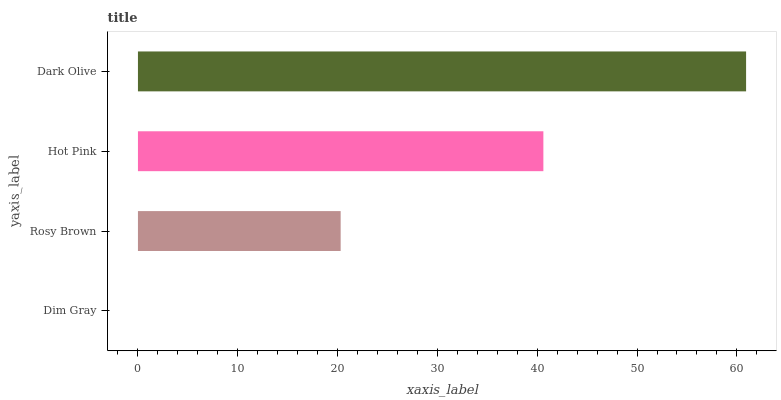Is Dim Gray the minimum?
Answer yes or no. Yes. Is Dark Olive the maximum?
Answer yes or no. Yes. Is Rosy Brown the minimum?
Answer yes or no. No. Is Rosy Brown the maximum?
Answer yes or no. No. Is Rosy Brown greater than Dim Gray?
Answer yes or no. Yes. Is Dim Gray less than Rosy Brown?
Answer yes or no. Yes. Is Dim Gray greater than Rosy Brown?
Answer yes or no. No. Is Rosy Brown less than Dim Gray?
Answer yes or no. No. Is Hot Pink the high median?
Answer yes or no. Yes. Is Rosy Brown the low median?
Answer yes or no. Yes. Is Dark Olive the high median?
Answer yes or no. No. Is Hot Pink the low median?
Answer yes or no. No. 